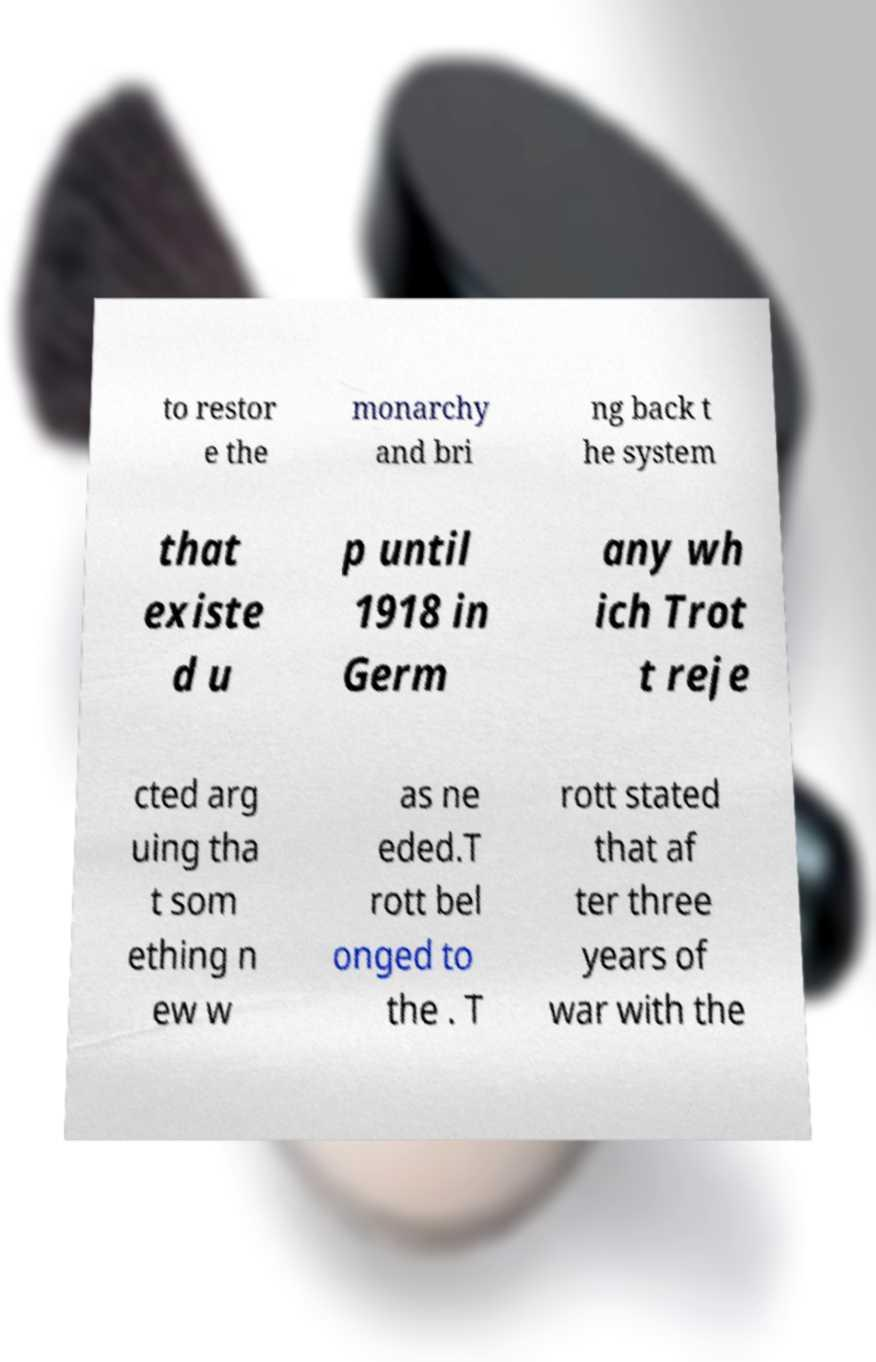Can you accurately transcribe the text from the provided image for me? to restor e the monarchy and bri ng back t he system that existe d u p until 1918 in Germ any wh ich Trot t reje cted arg uing tha t som ething n ew w as ne eded.T rott bel onged to the . T rott stated that af ter three years of war with the 